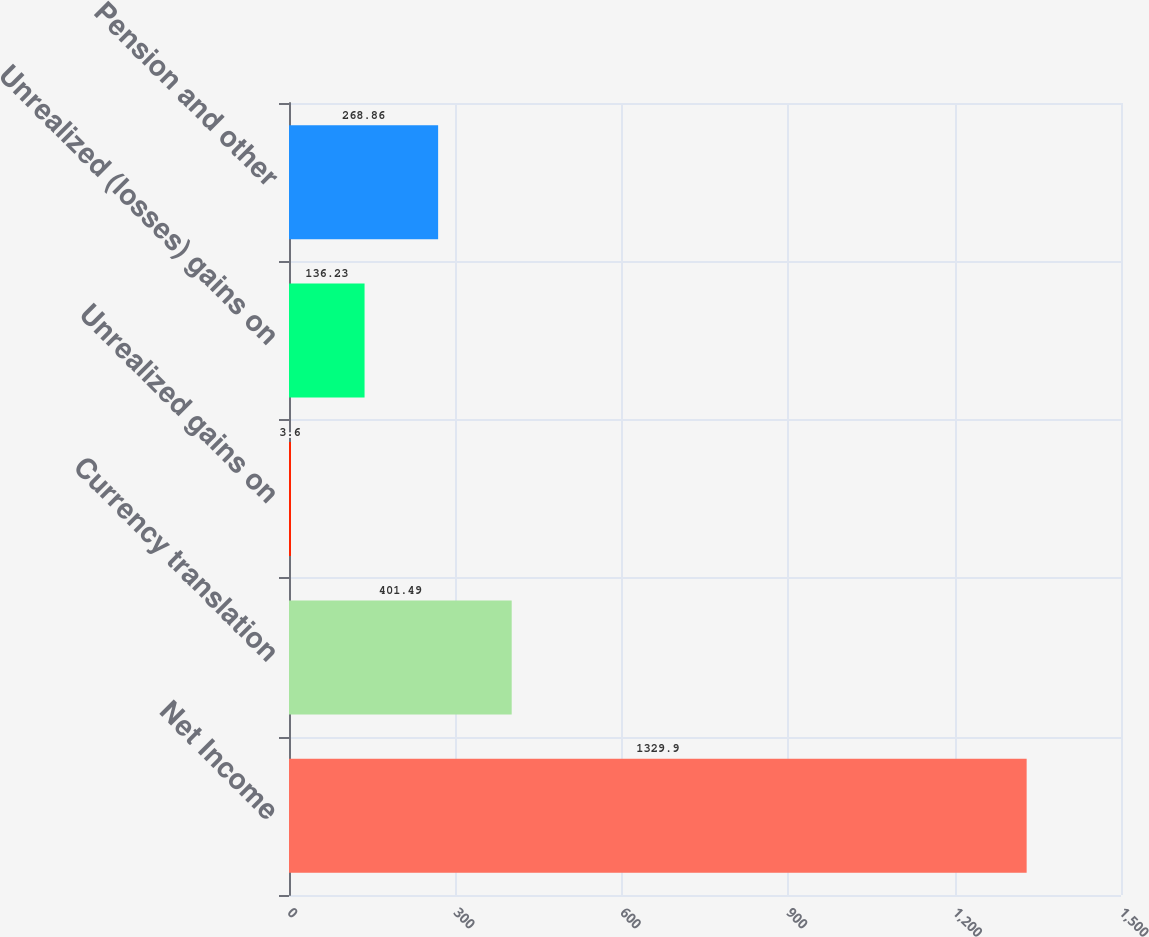<chart> <loc_0><loc_0><loc_500><loc_500><bar_chart><fcel>Net Income<fcel>Currency translation<fcel>Unrealized gains on<fcel>Unrealized (losses) gains on<fcel>Pension and other<nl><fcel>1329.9<fcel>401.49<fcel>3.6<fcel>136.23<fcel>268.86<nl></chart> 